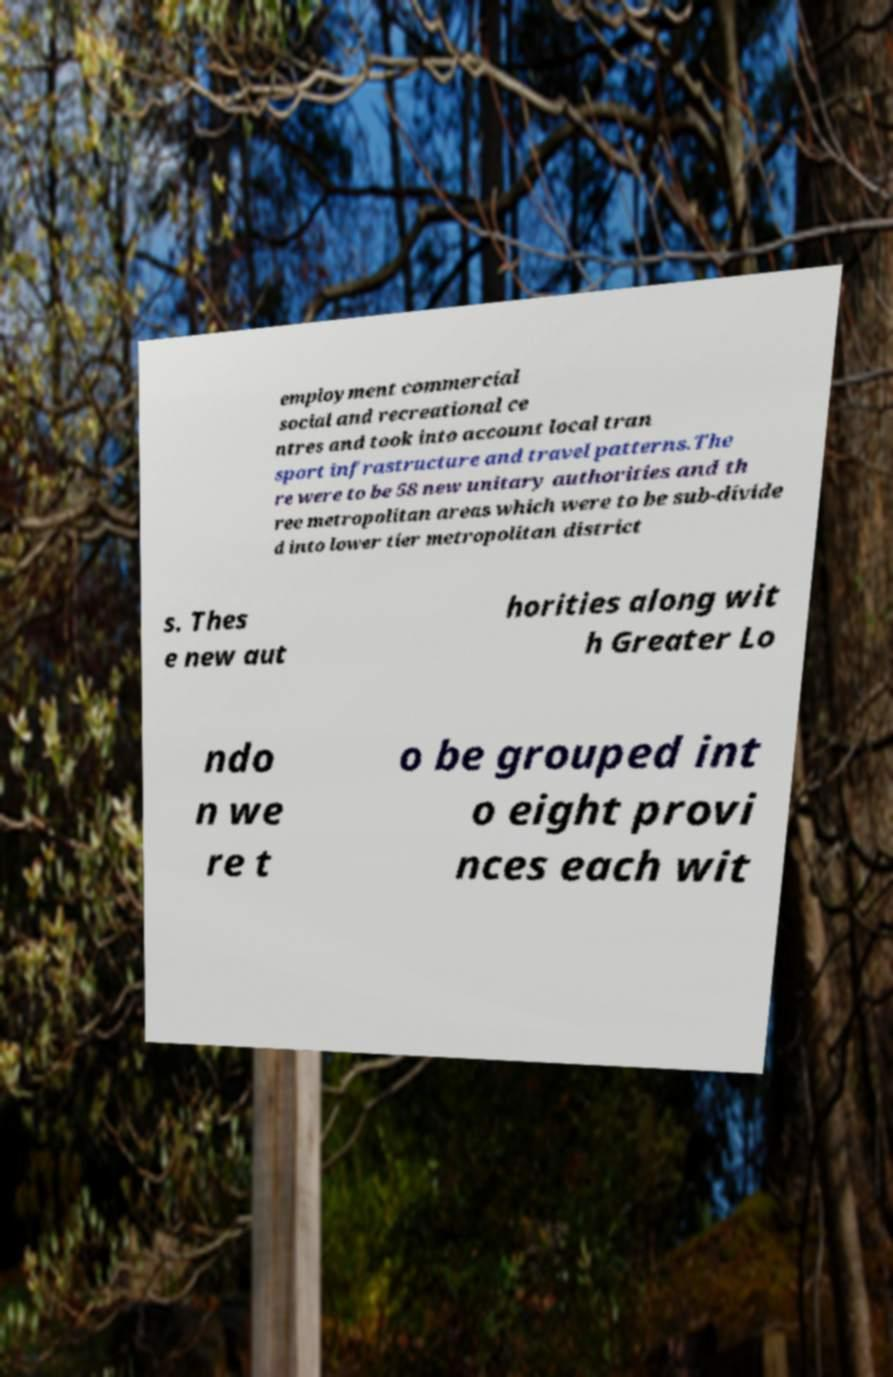Can you read and provide the text displayed in the image?This photo seems to have some interesting text. Can you extract and type it out for me? employment commercial social and recreational ce ntres and took into account local tran sport infrastructure and travel patterns.The re were to be 58 new unitary authorities and th ree metropolitan areas which were to be sub-divide d into lower tier metropolitan district s. Thes e new aut horities along wit h Greater Lo ndo n we re t o be grouped int o eight provi nces each wit 